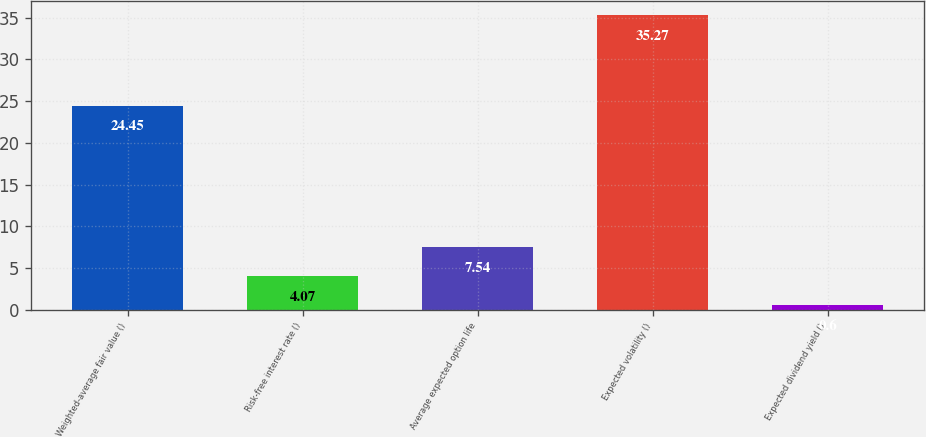Convert chart to OTSL. <chart><loc_0><loc_0><loc_500><loc_500><bar_chart><fcel>Weighted-average fair value ()<fcel>Risk-free interest rate ()<fcel>Average expected option life<fcel>Expected volatility ()<fcel>Expected dividend yield ()<nl><fcel>24.45<fcel>4.07<fcel>7.54<fcel>35.27<fcel>0.6<nl></chart> 